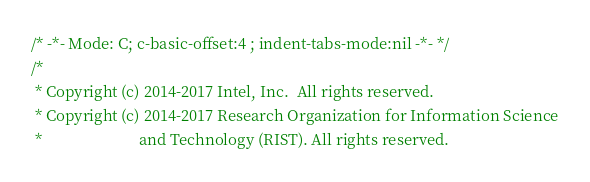Convert code to text. <code><loc_0><loc_0><loc_500><loc_500><_C_>/* -*- Mode: C; c-basic-offset:4 ; indent-tabs-mode:nil -*- */
/*
 * Copyright (c) 2014-2017 Intel, Inc.  All rights reserved.
 * Copyright (c) 2014-2017 Research Organization for Information Science
 *                         and Technology (RIST). All rights reserved.</code> 